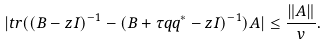Convert formula to latex. <formula><loc_0><loc_0><loc_500><loc_500>| t r ( ( B - z I ) ^ { - 1 } - ( B + \tau q q ^ { * } - z I ) ^ { - 1 } ) A | \leq \frac { \| A \| } { v } .</formula> 